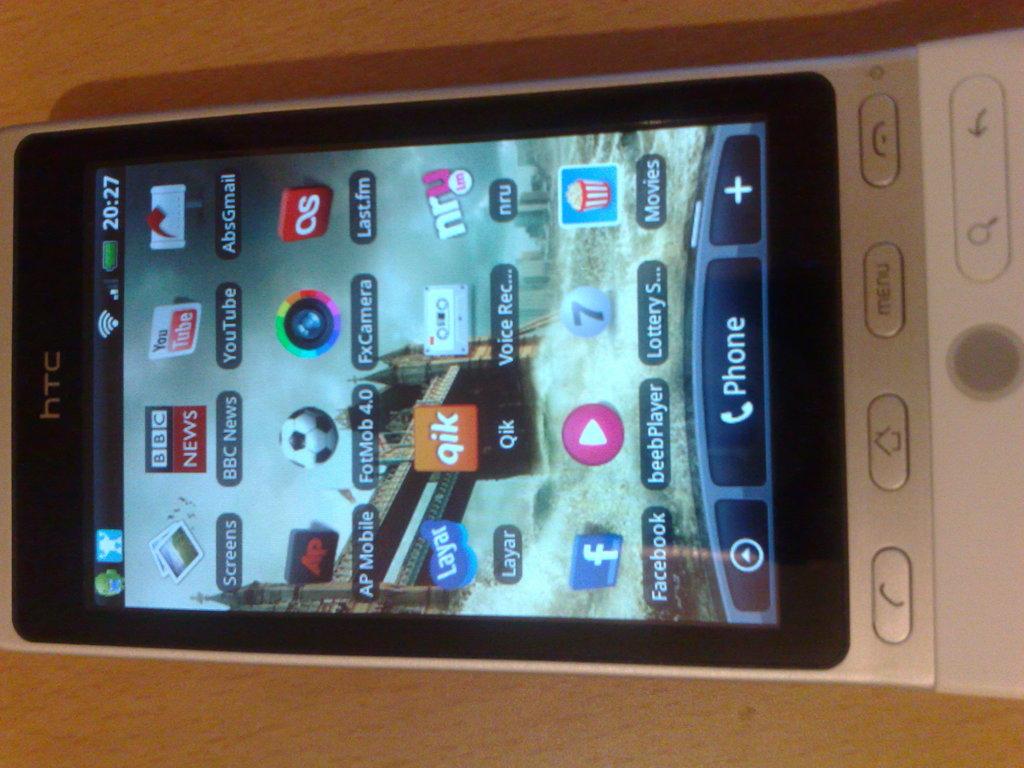Who makes the phone?
Your answer should be compact. Htc. What is the orange app on the phone?
Offer a very short reply. Qik. 